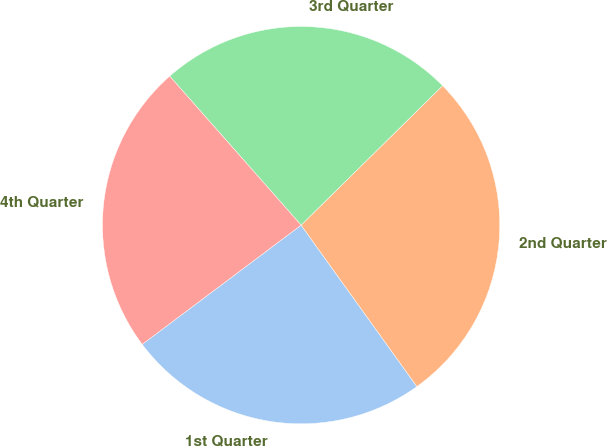Convert chart to OTSL. <chart><loc_0><loc_0><loc_500><loc_500><pie_chart><fcel>1st Quarter<fcel>2nd Quarter<fcel>3rd Quarter<fcel>4th Quarter<nl><fcel>24.66%<fcel>27.48%<fcel>24.12%<fcel>23.74%<nl></chart> 